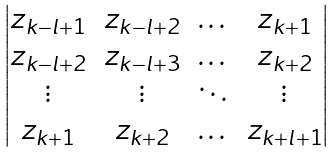Convert formula to latex. <formula><loc_0><loc_0><loc_500><loc_500>\begin{vmatrix} z _ { k - l + 1 } & z _ { k - l + 2 } & \dots & z _ { k + 1 } \\ z _ { k - l + 2 } & z _ { k - l + 3 } & \dots & z _ { k + 2 } \\ \vdots & \vdots & \ddots & \vdots \\ z _ { k + 1 } & z _ { k + 2 } & \dots & z _ { k + l + 1 } \end{vmatrix}</formula> 